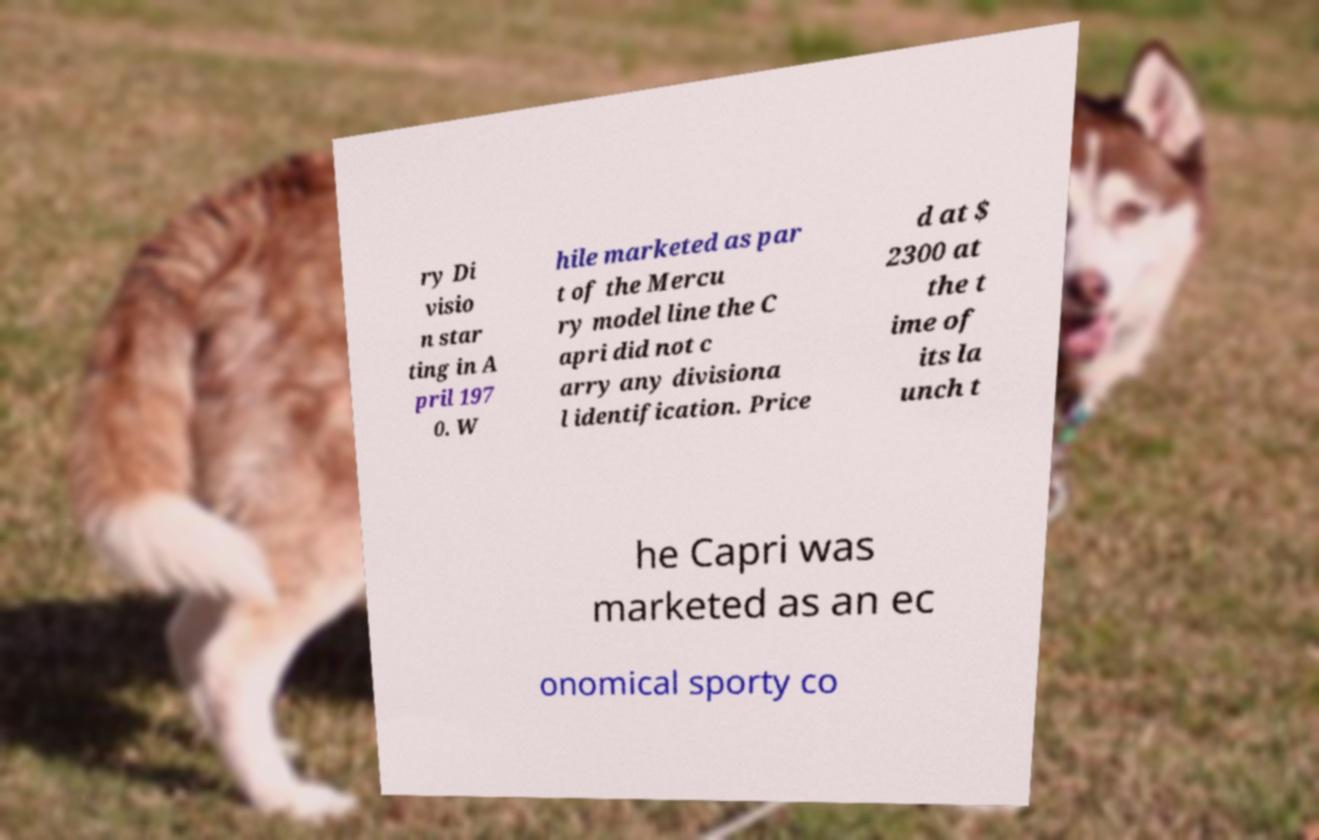Please read and relay the text visible in this image. What does it say? ry Di visio n star ting in A pril 197 0. W hile marketed as par t of the Mercu ry model line the C apri did not c arry any divisiona l identification. Price d at $ 2300 at the t ime of its la unch t he Capri was marketed as an ec onomical sporty co 